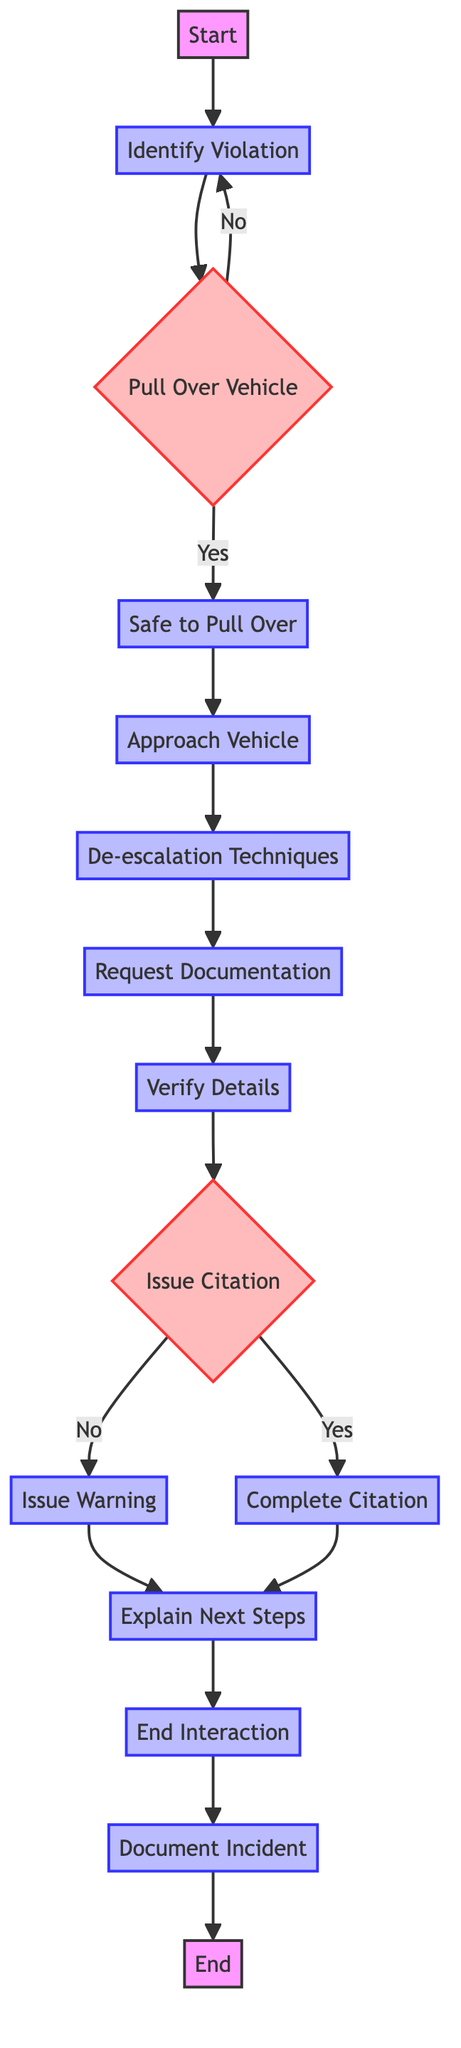What is the first step in the process? The first step, as indicated in the diagram, is "Start". This is where the traffic violation handling process begins.
Answer: Start How many decision nodes are in the diagram? The diagram contains two decision nodes: "Pull Over Vehicle" and "Issue Citation". This can be counted by identifying nodes with branching paths, which indicate a decision point.
Answer: 2 What follows after "Approach Vehicle"? After "Approach Vehicle", the next step is "De-escalation Techniques". This is determined by following the arrow from "Approach Vehicle" to the next process in the flow.
Answer: De-escalation Techniques What should an officer do if the vehicle cannot be safely pulled over? If the vehicle cannot be safely pulled over, the officer would return to the "Identify Violation" step according to the flowchart. This indicates a loop back to reassess the situation.
Answer: Identify Violation What happens after a warning is issued? After issuing a warning, the officer moves to "Explain Next Steps". This indicates that the next action involves communicating further information to the driver.
Answer: Explain Next Steps What is the last step in the process? The last step in the traffic violation handling process is "End". This indicates the conclusion of all actions taken in the process.
Answer: End What are the mandatory documents requested by the officer? The officer requests the driver’s license, registration, and proof of insurance. These specific documents are listed in the "Request Documentation" step.
Answer: Driver's license, registration, proof of insurance What action is taken after verifying details? After verifying details, the officer decides whether to "Issue Citation". This is determined by continuing the flow from the "Verify Details" process.
Answer: Issue Citation How does the process conclude after the interaction? The process concludes after documenting the incident and the citation, leading to the final "End" step of the diagram. This indicates that all necessary actions have been recorded and the process is complete.
Answer: End 